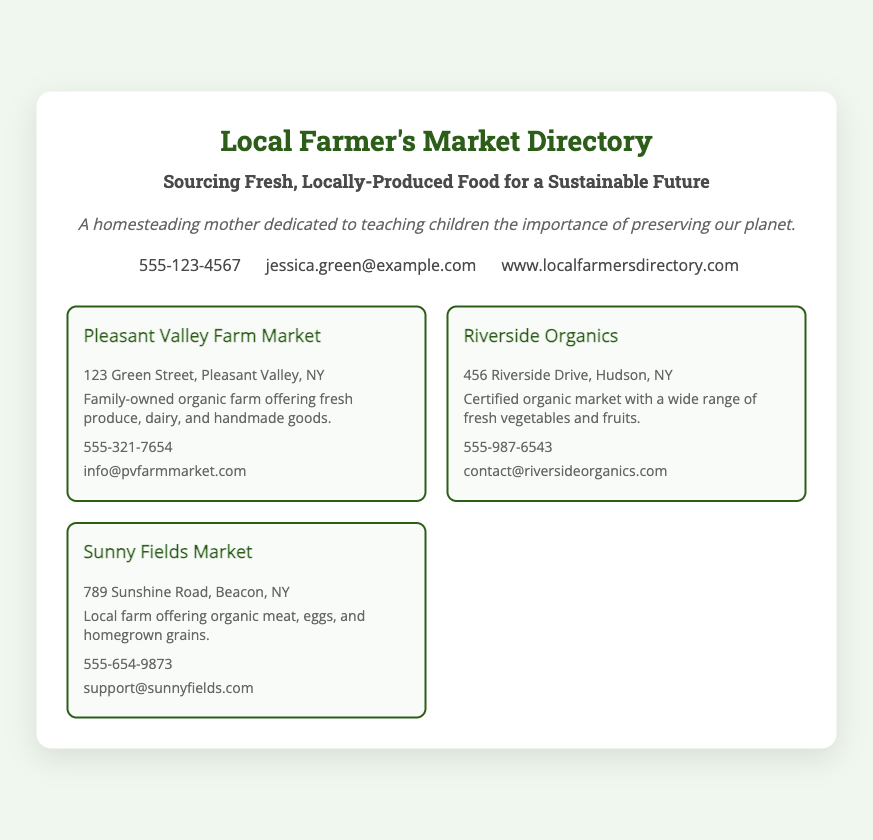What is the name of the directory? The document highlights a "Local Farmer's Market Directory" as its main title.
Answer: Local Farmer's Market Directory What is the primary focus of the directory? The directory emphasizes sourcing "Fresh, Locally-Produced Food for a Sustainable Future."
Answer: Fresh, Locally-Produced Food What is the contact phone number provided? The document lists a phone number in the contact info section: "555-123-4567."
Answer: 555-123-4567 How many featured markets are listed? There are three markets mentioned in the featured markets section of the document.
Answer: Three What is the address of Riverside Organics? The address for Riverside Organics is located in the text: "456 Riverside Drive, Hudson, NY."
Answer: 456 Riverside Drive, Hudson, NY Who owns Pleasant Valley Farm Market? The description states that it is a "Family-owned organic farm."
Answer: Family-owned What type of products does Sunny Fields Market offer? The market description includes "organic meat, eggs, and homegrown grains."
Answer: Organic meat, eggs, and homegrown grains What email address is provided for contact? The email address for contact in the document is "jessica.green@example.com."
Answer: jessica.green@example.com Where can more information about the directory be found online? The directory provides a link in the contact info: "www.localfarmersdirectory.com."
Answer: www.localfarmersdirectory.com 